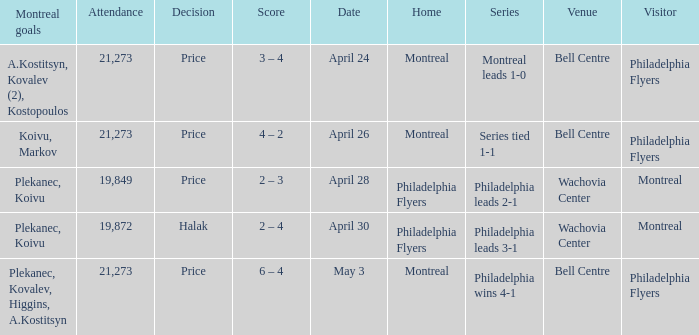What was the average attendance when the decision was price and montreal were the visitors? 19849.0. 